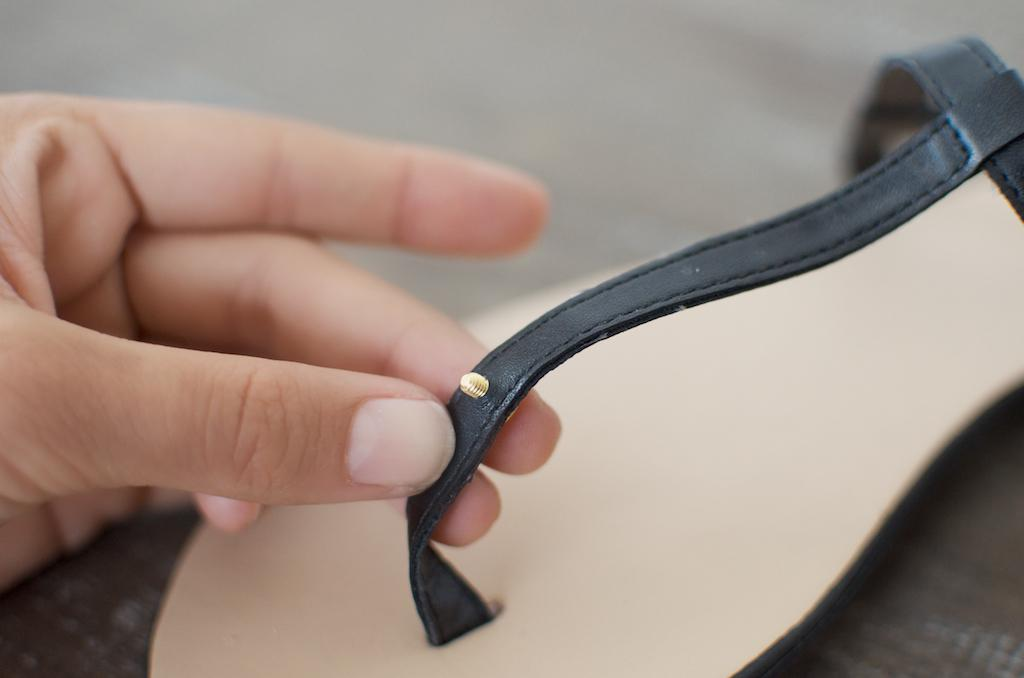What can be seen in the image related to a person's hand? There is a person's hand in the image, and it is holding a black color belt. Can you describe the color belt being held in the image? The color belt being held is black. What can be observed about the background of the image? The background of the image is blurred. What type of reaction can be seen on the calculator in the image? There is no calculator present in the image, so no reaction can be observed on it. 